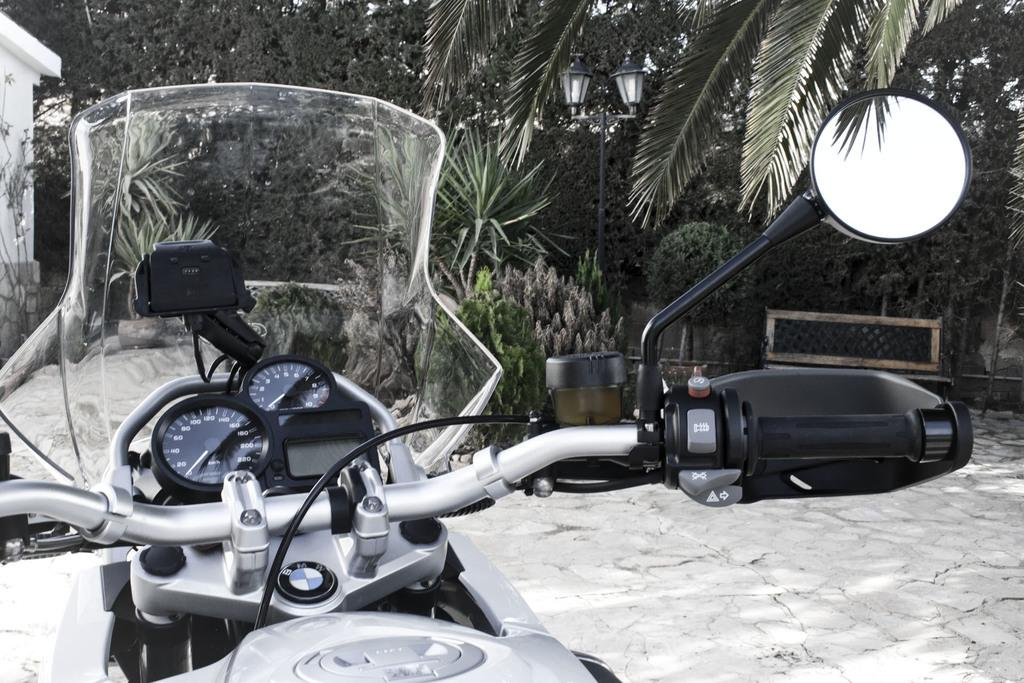What is the main subject of the image? There is a motorbike in the image. What can be seen in the background of the image? There are trees, plants, and a pole in the background of the image. What is located on the right side of the image? There is a bench on the right side of the image. What is located on the left side of the image? There is a building on the left side of the image. How many centimeters of coal can be seen on the motorbike in the image? There is no coal present on the motorbike in the image. What type of cork is used to secure the plants in the background of the image? There is no cork visible in the image, as it focuses on the motorbike and the surrounding environment. 